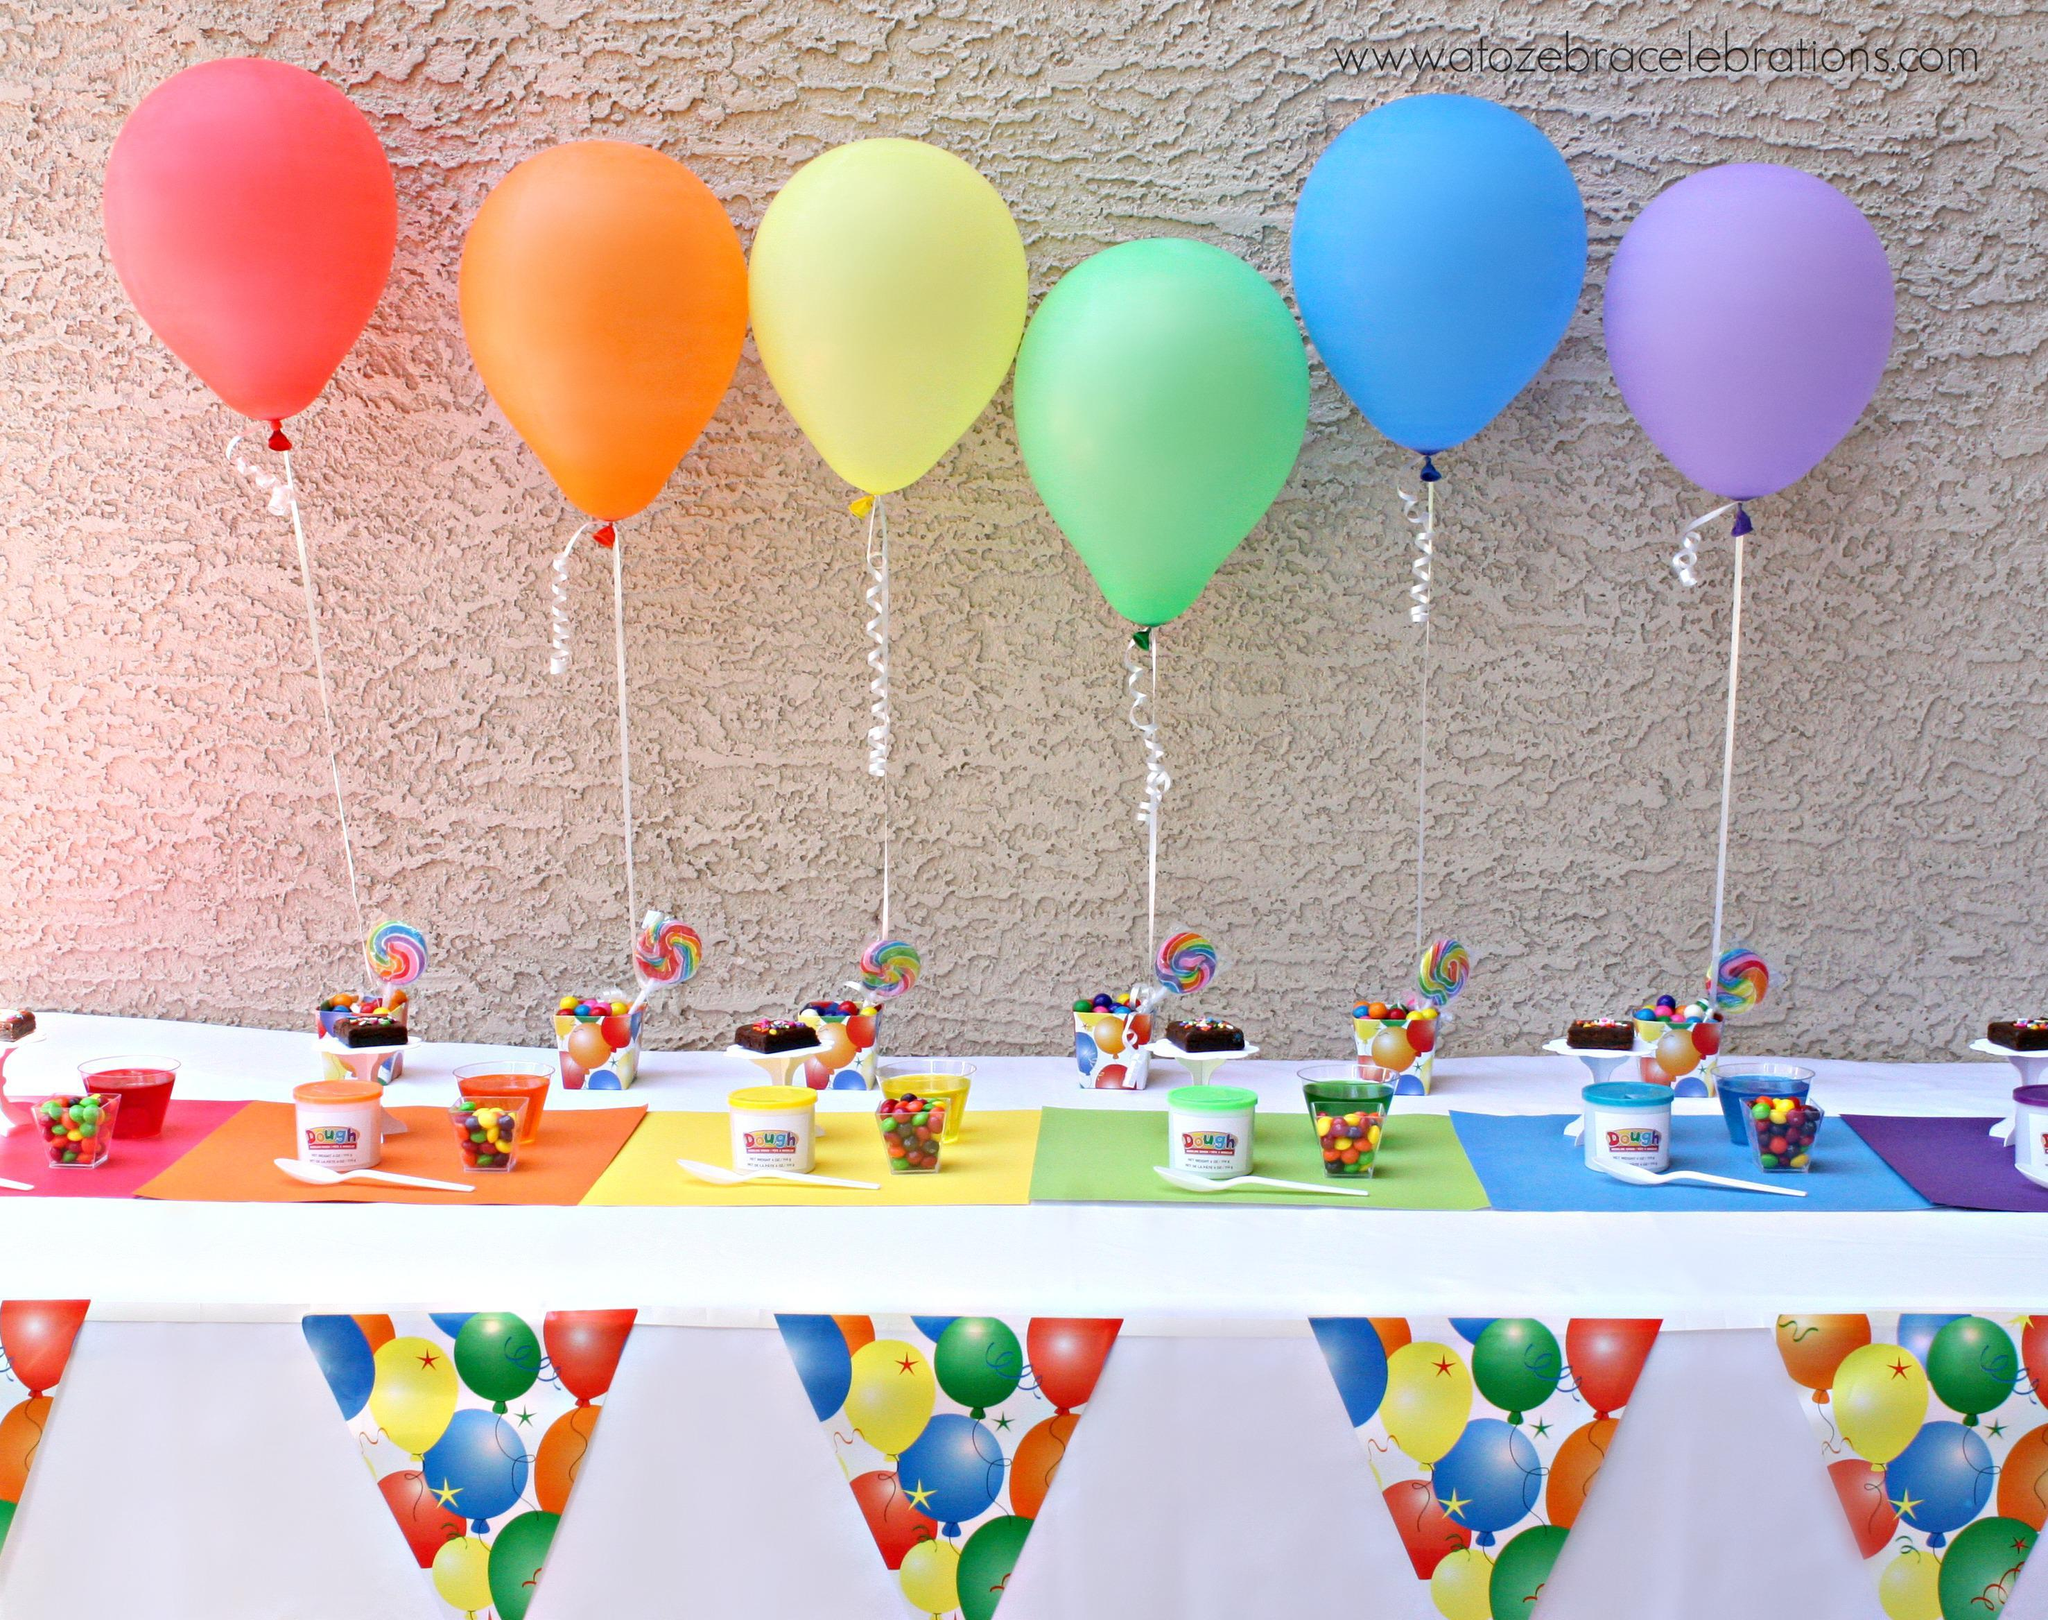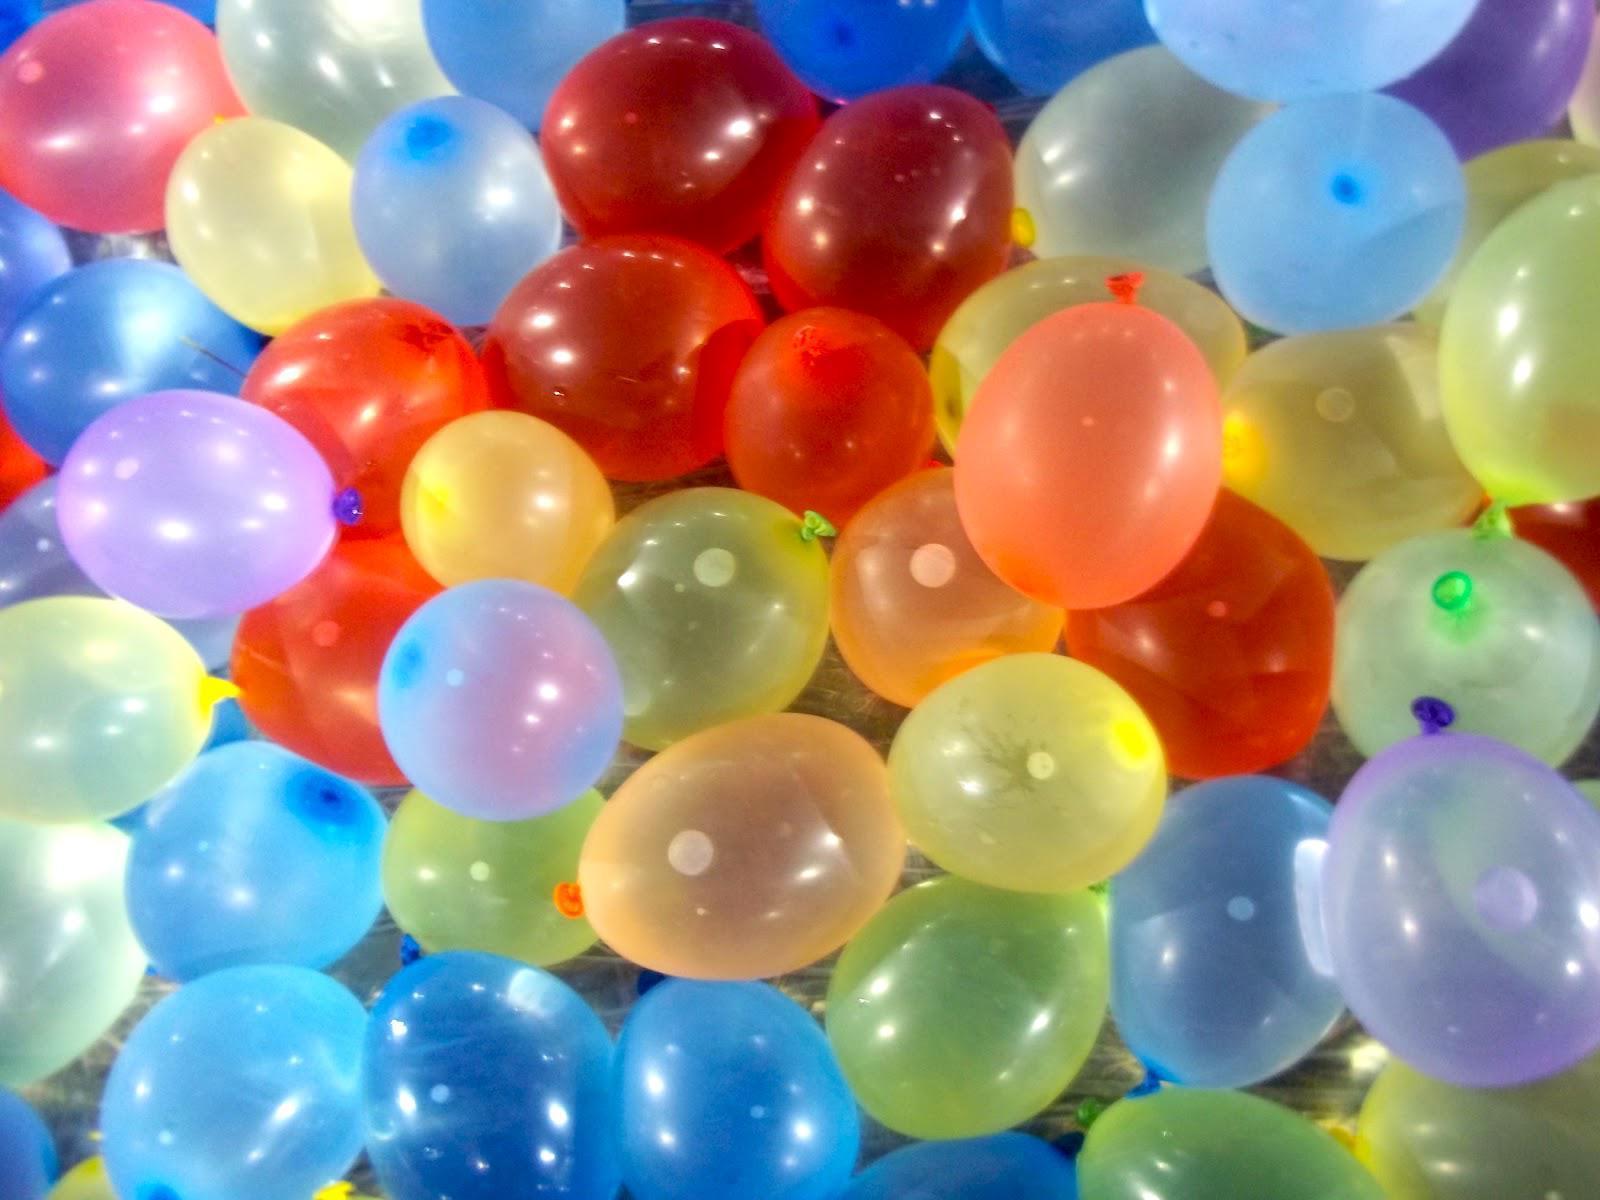The first image is the image on the left, the second image is the image on the right. For the images shown, is this caption "Each image shows one bunch of different colored balloons with strings hanging down, and no bunch contains more than 10 balloons." true? Answer yes or no. No. The first image is the image on the left, the second image is the image on the right. Examine the images to the left and right. Is the description "In at least one image there are six different colored balloons." accurate? Answer yes or no. Yes. 